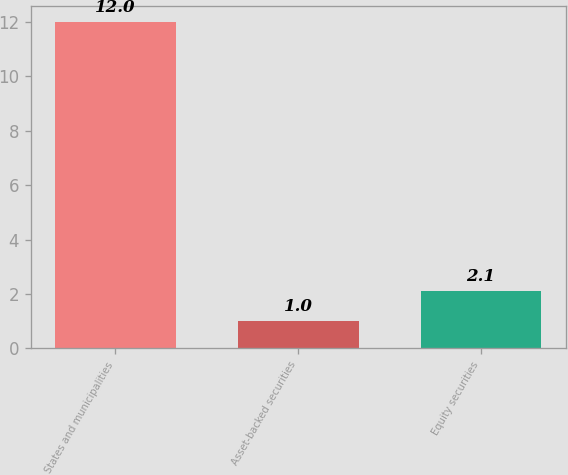Convert chart to OTSL. <chart><loc_0><loc_0><loc_500><loc_500><bar_chart><fcel>States and municipalities<fcel>Asset-backed securities<fcel>Equity securities<nl><fcel>12<fcel>1<fcel>2.1<nl></chart> 